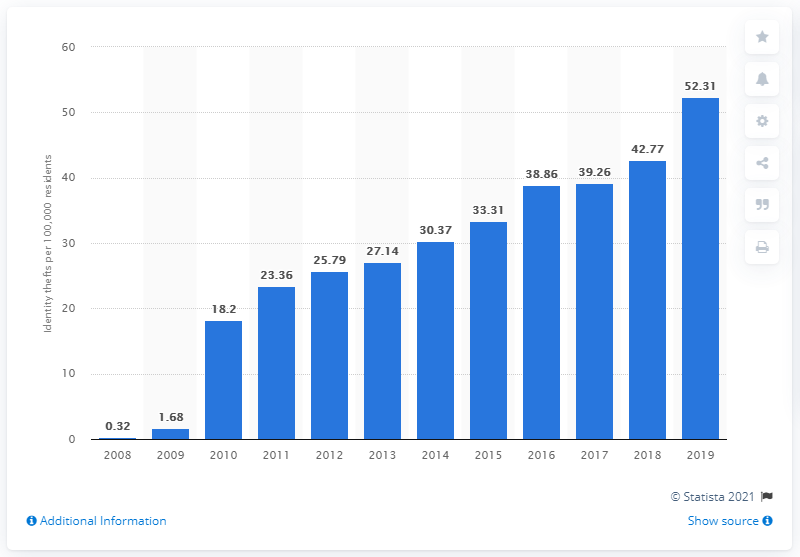Indicate a few pertinent items in this graphic. In 2019, there were 52.31 incidents of identity fraud per 100,000 residents in Canada. 